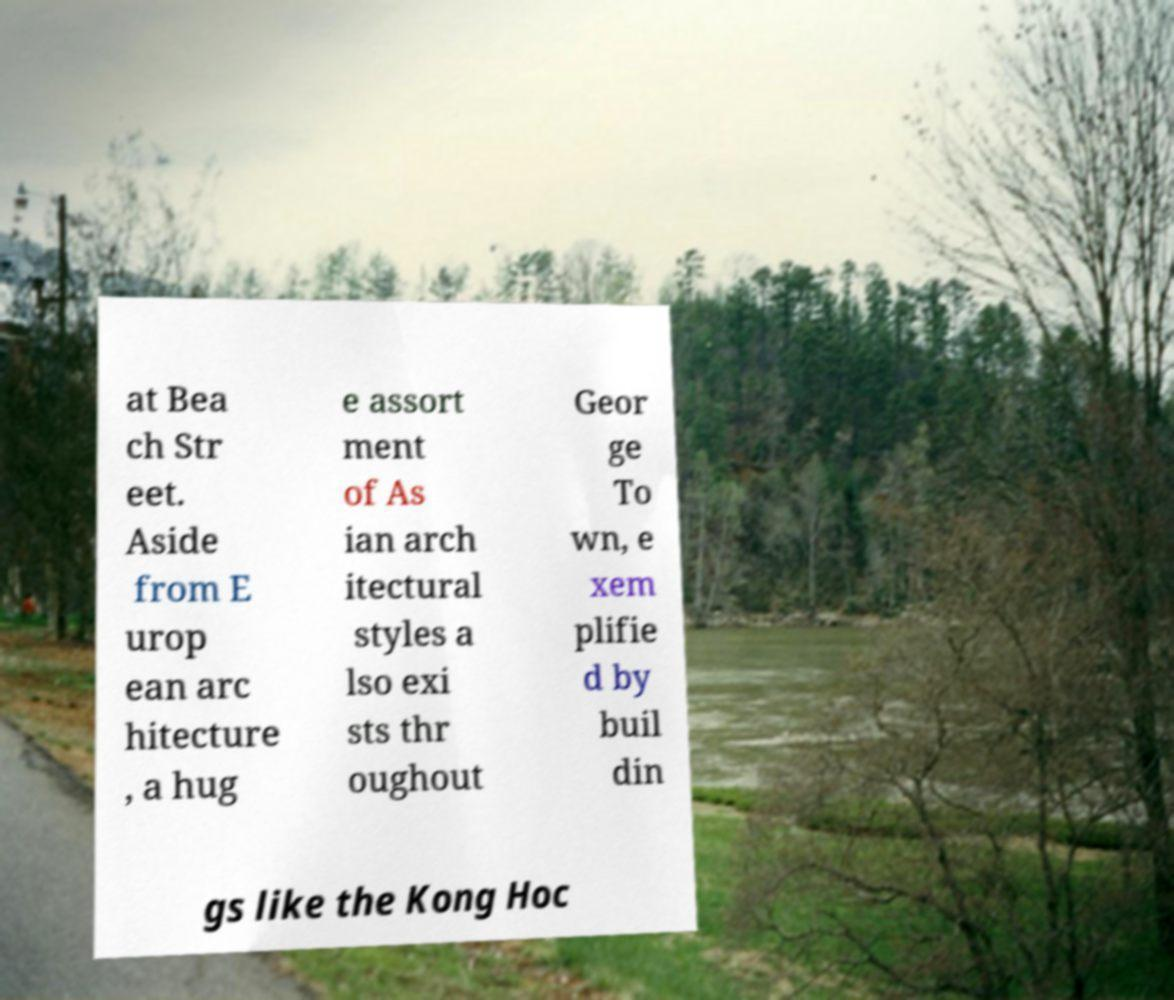Can you accurately transcribe the text from the provided image for me? at Bea ch Str eet. Aside from E urop ean arc hitecture , a hug e assort ment of As ian arch itectural styles a lso exi sts thr oughout Geor ge To wn, e xem plifie d by buil din gs like the Kong Hoc 